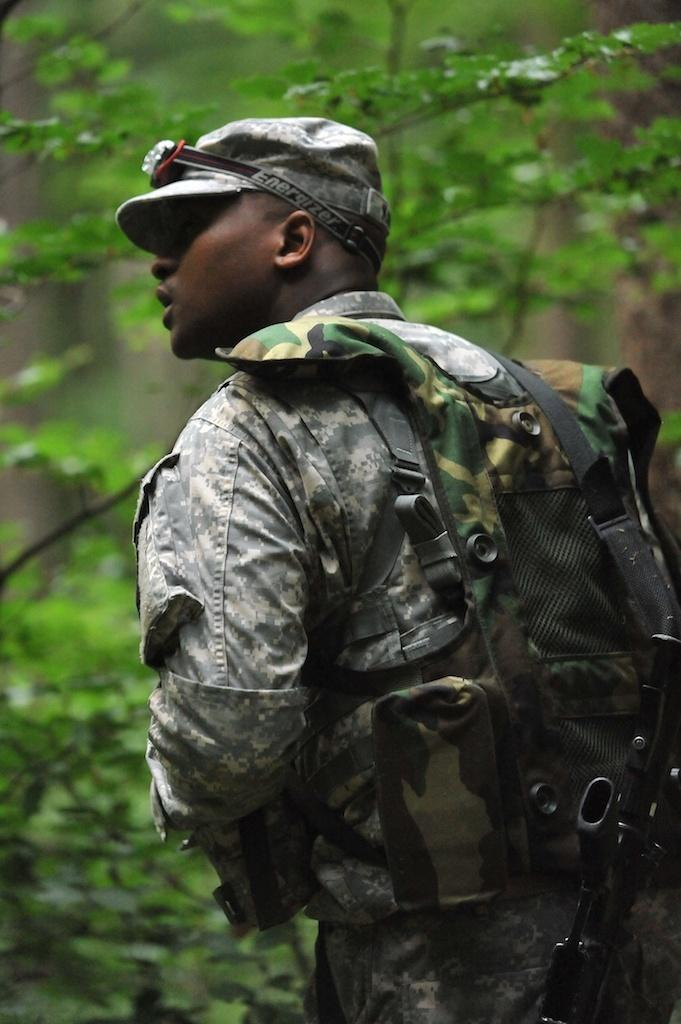What is the main subject of the image? There is a person standing in the middle of the image. What can be seen in the background of the image? There are trees in front of the person. What type of form does the person need to fill out in the image? There is no form present in the image, so it cannot be determined if the person needs to fill out any form. 